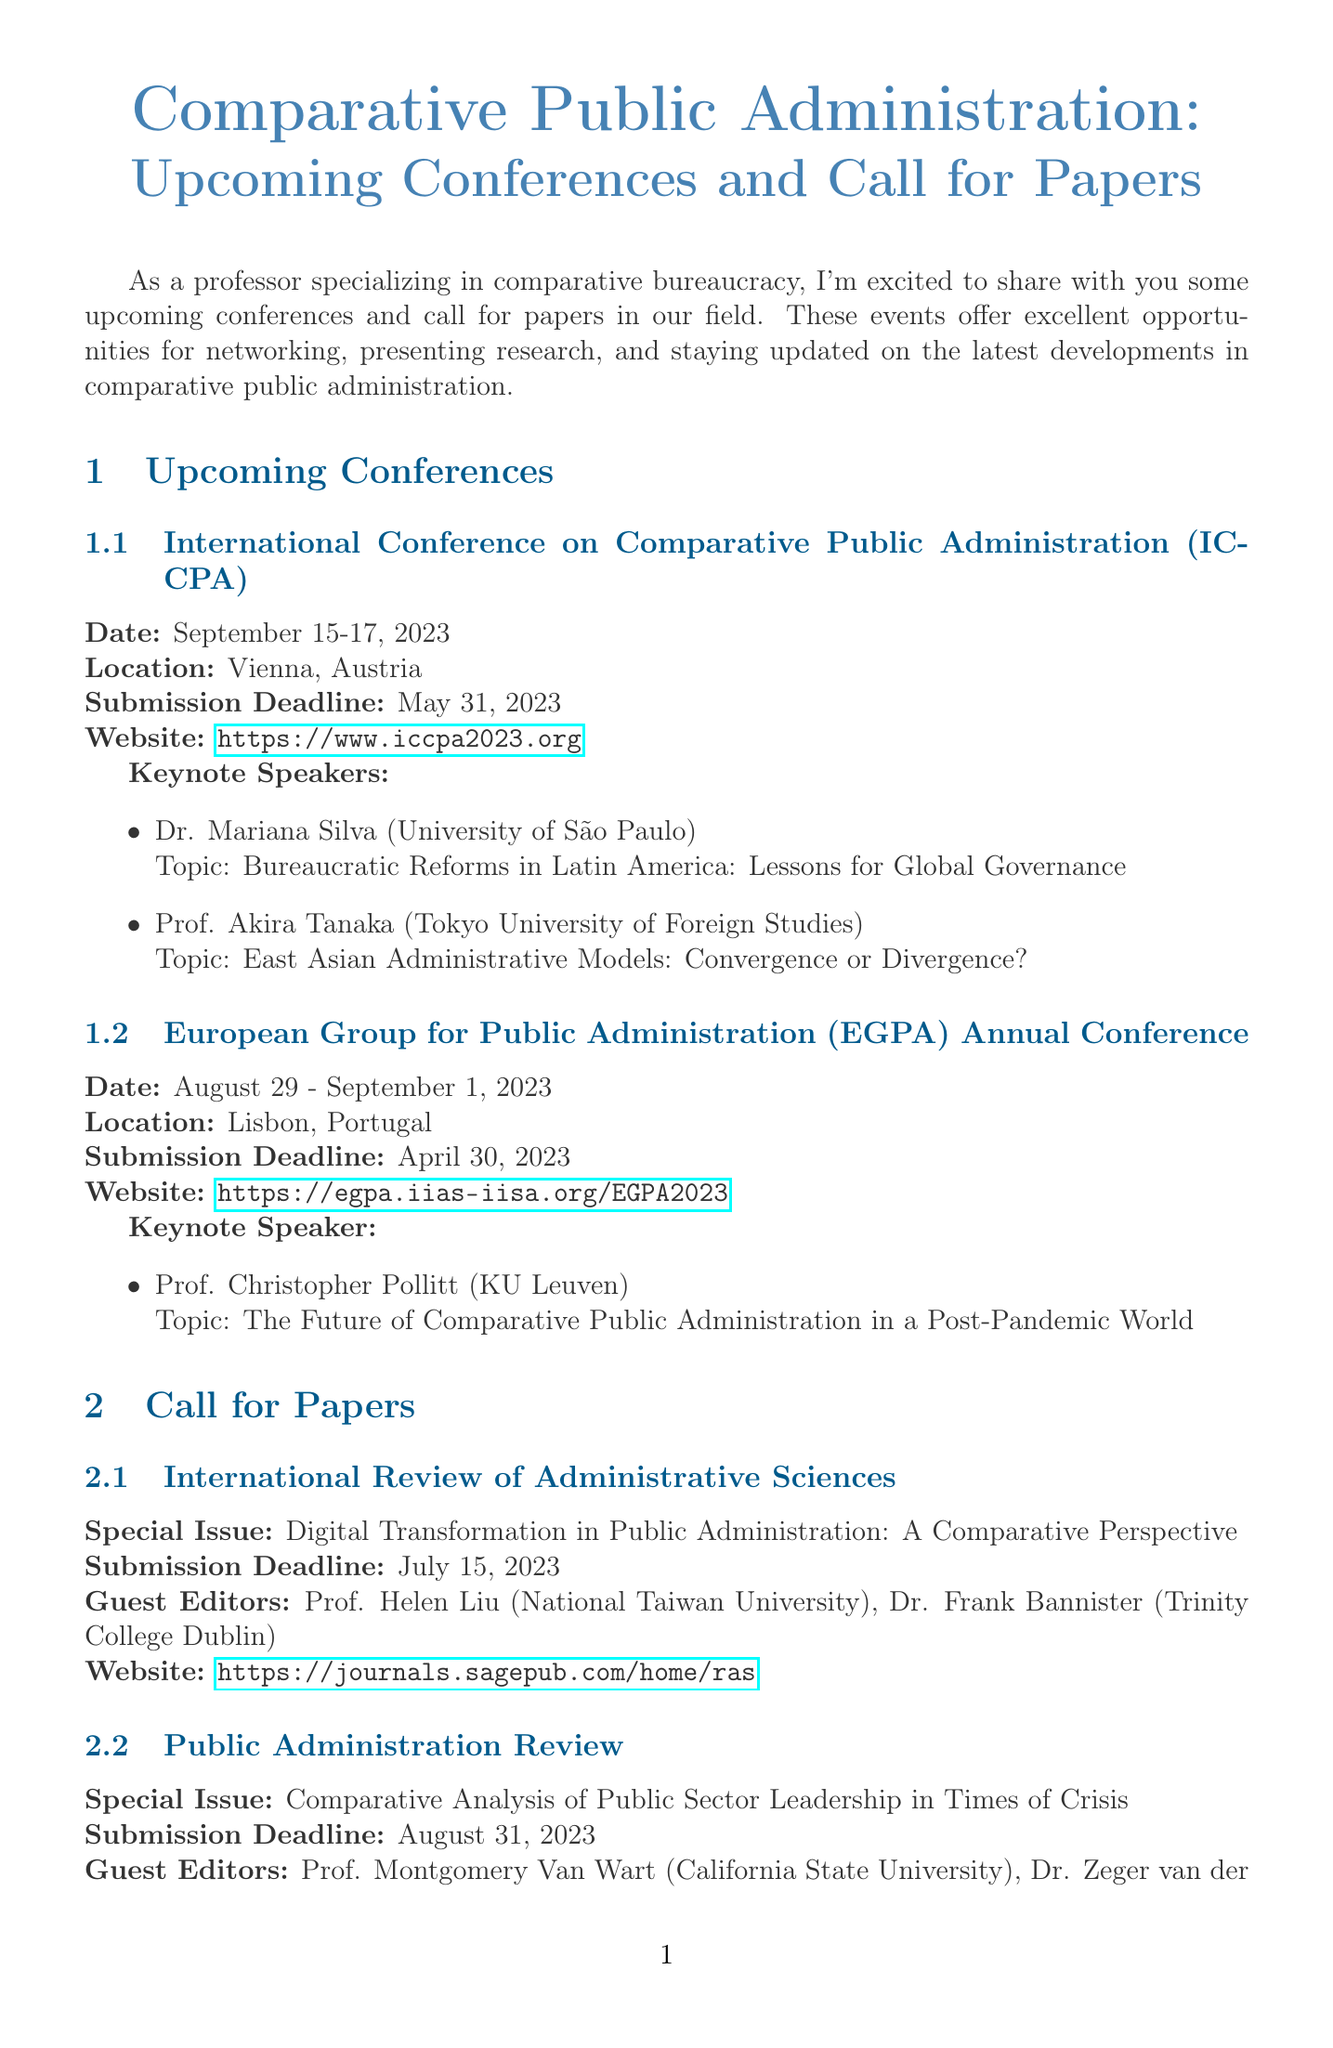What is the date of the ICCPA conference? The date of the ICCPA conference is mentioned directly in the document, which is September 15-17, 2023.
Answer: September 15-17, 2023 Who is the keynote speaker at the EGPA Annual Conference? The keynote speaker for the EGPA Annual Conference is identified in the document, which is Prof. Christopher Pollitt.
Answer: Prof. Christopher Pollitt What is the submission deadline for the special issue in the International Review of Administrative Sciences? The submission deadline for the special issue is provided in the document as July 15, 2023.
Answer: July 15, 2023 Where is the European Group for Public Administration Annual Conference held? The location of the EGPA Annual Conference is specified in the document as Lisbon, Portugal.
Answer: Lisbon, Portugal What is the focus of the Fulbright Scholar Program? The focus of the Fulbright Scholar Program is stated in the document, which is Comparative Public Administration Research.
Answer: Comparative Public Administration Research How many keynote speakers were listed for the ICCPA conference? The document lists the number of keynote speakers for the ICCPA conference, which is two.
Answer: Two What special issue is being called for in the Public Administration Review? The special issue for the Public Administration Review is mentioned in the document as Comparative Analysis of Public Sector Leadership in Times of Crisis.
Answer: Comparative Analysis of Public Sector Leadership in Times of Crisis What year was "Comparative Public Administration: The Essential Readings" published? The publication year for "Comparative Public Administration: The Essential Readings" is included in the document as 2023.
Answer: 2023 